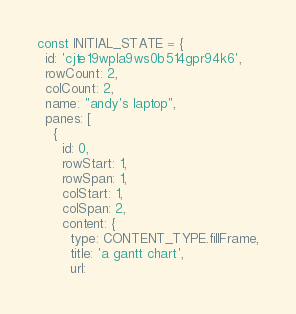Convert code to text. <code><loc_0><loc_0><loc_500><loc_500><_JavaScript_>const INITIAL_STATE = {
  id: 'cjte19wpla9ws0b514gpr94k6',
  rowCount: 2,
  colCount: 2,
  name: "andy's laptop",
  panes: [
    {
      id: 0,
      rowStart: 1,
      rowSpan: 1,
      colStart: 1,
      colSpan: 2,
      content: {
        type: CONTENT_TYPE.fillFrame,
        title: 'a gantt chart',
        url:</code> 